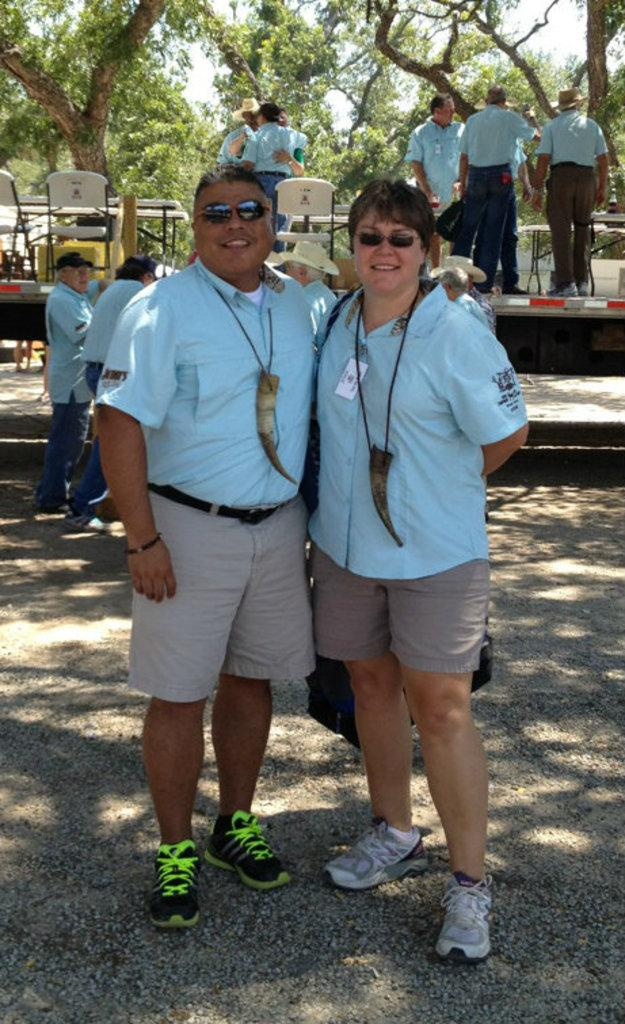How many people are visible in the image? There are two people standing in the image. What is the facial expression of the people in the image? The two people are smiling. Can you describe the background of the image? There are people, chairs, and trees in the background of the image. What type of bulb is being used to illuminate the basketball court in the image? There is no basketball court or bulb present in the image. What is the profit margin of the people in the image? There is no information about profit margins in the image, as it only shows two people standing and smiling. 